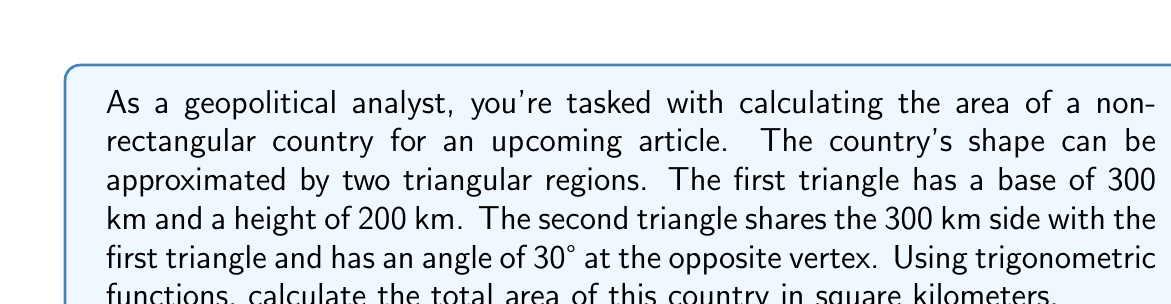Solve this math problem. Let's approach this step-by-step:

1) For the first triangle, we can use the simple area formula:
   $$A_1 = \frac{1}{2} \times base \times height$$
   $$A_1 = \frac{1}{2} \times 300 \times 200 = 30,000 \text{ km}^2$$

2) For the second triangle, we need to use trigonometry:
   - We know one side (300 km) and one angle (30°)
   - We can use the sine function to find the area

3) The formula for the area of a triangle using sine is:
   $$A = \frac{1}{2} \times a \times b \times \sin(C)$$
   Where $a$ and $b$ are two sides, and $C$ is the angle between them

4) In our case:
   $$A_2 = \frac{1}{2} \times 300 \times 300 \times \sin(30°)$$

5) Simplify:
   $$A_2 = \frac{1}{2} \times 90,000 \times \frac{1}{2} = 22,500 \text{ km}^2$$

6) The total area is the sum of both triangles:
   $$A_{total} = A_1 + A_2 = 30,000 + 22,500 = 52,500 \text{ km}^2$$

[asy]
import geometry;

size(200);

pair A = (0,0);
pair B = (6,0);
pair C = (0,4);
pair D = (6,3.464);

draw(A--B--C--cycle);
draw(A--B--D--cycle);

label("300 km", (3,-0.3), S);
label("200 km", (-0.3,2), W);
label("30°", (5.7,0.5), E);

dot(A); dot(B); dot(C); dot(D);
[/asy]
Answer: 52,500 km² 